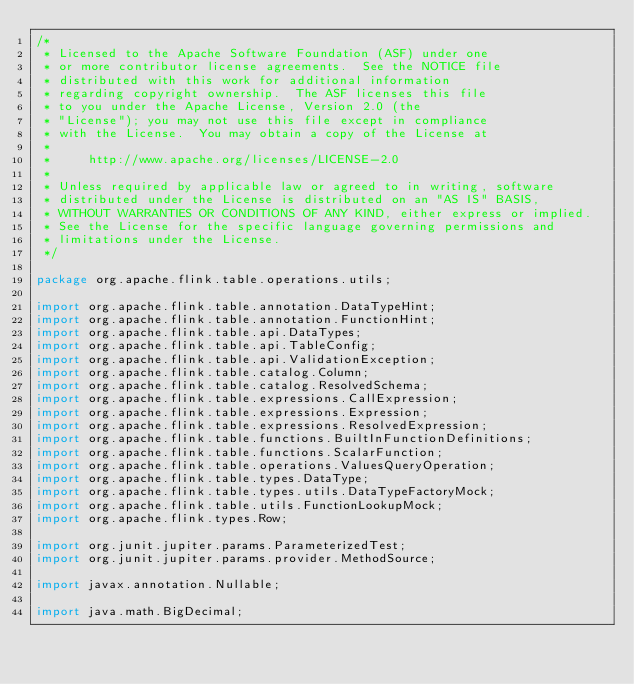<code> <loc_0><loc_0><loc_500><loc_500><_Java_>/*
 * Licensed to the Apache Software Foundation (ASF) under one
 * or more contributor license agreements.  See the NOTICE file
 * distributed with this work for additional information
 * regarding copyright ownership.  The ASF licenses this file
 * to you under the Apache License, Version 2.0 (the
 * "License"); you may not use this file except in compliance
 * with the License.  You may obtain a copy of the License at
 *
 *     http://www.apache.org/licenses/LICENSE-2.0
 *
 * Unless required by applicable law or agreed to in writing, software
 * distributed under the License is distributed on an "AS IS" BASIS,
 * WITHOUT WARRANTIES OR CONDITIONS OF ANY KIND, either express or implied.
 * See the License for the specific language governing permissions and
 * limitations under the License.
 */

package org.apache.flink.table.operations.utils;

import org.apache.flink.table.annotation.DataTypeHint;
import org.apache.flink.table.annotation.FunctionHint;
import org.apache.flink.table.api.DataTypes;
import org.apache.flink.table.api.TableConfig;
import org.apache.flink.table.api.ValidationException;
import org.apache.flink.table.catalog.Column;
import org.apache.flink.table.catalog.ResolvedSchema;
import org.apache.flink.table.expressions.CallExpression;
import org.apache.flink.table.expressions.Expression;
import org.apache.flink.table.expressions.ResolvedExpression;
import org.apache.flink.table.functions.BuiltInFunctionDefinitions;
import org.apache.flink.table.functions.ScalarFunction;
import org.apache.flink.table.operations.ValuesQueryOperation;
import org.apache.flink.table.types.DataType;
import org.apache.flink.table.types.utils.DataTypeFactoryMock;
import org.apache.flink.table.utils.FunctionLookupMock;
import org.apache.flink.types.Row;

import org.junit.jupiter.params.ParameterizedTest;
import org.junit.jupiter.params.provider.MethodSource;

import javax.annotation.Nullable;

import java.math.BigDecimal;</code> 